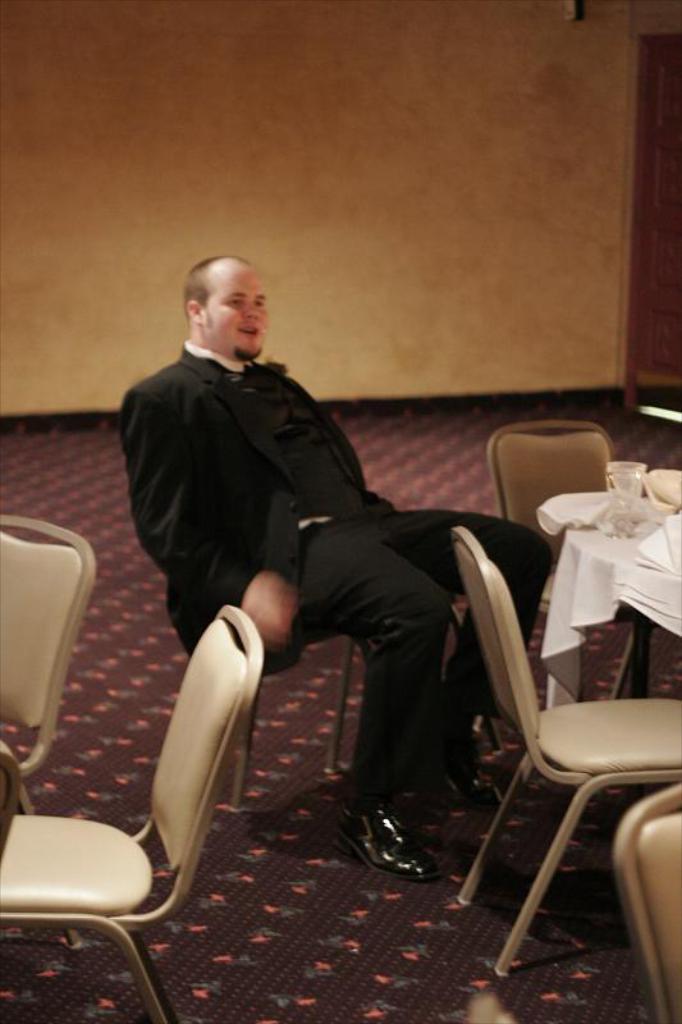Could you give a brief overview of what you see in this image? In this image I see a man who is sitting and there are 5 chairs over here and there is a table and few things on it. In the background I see the wall. 